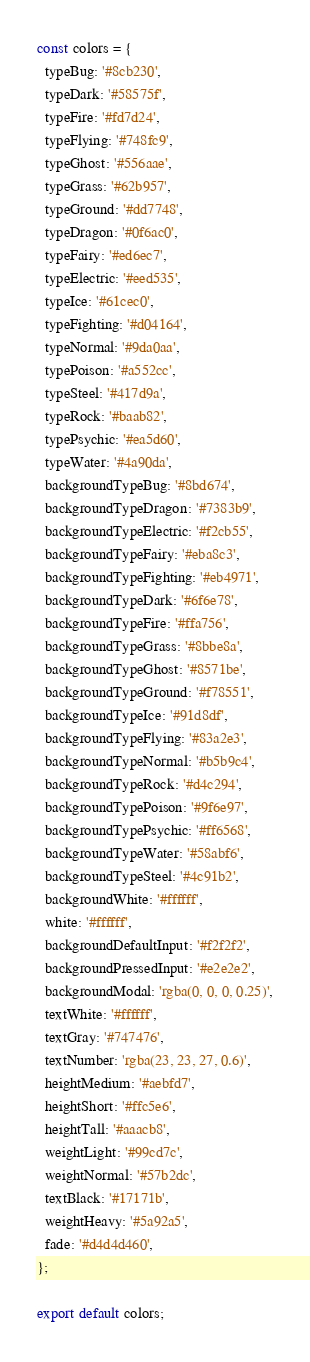<code> <loc_0><loc_0><loc_500><loc_500><_JavaScript_>const colors = {
  typeBug: '#8cb230',
  typeDark: '#58575f',
  typeFire: '#fd7d24',
  typeFlying: '#748fc9',
  typeGhost: '#556aae',
  typeGrass: '#62b957',
  typeGround: '#dd7748',
  typeDragon: '#0f6ac0',
  typeFairy: '#ed6ec7',
  typeElectric: '#eed535',
  typeIce: '#61cec0',
  typeFighting: '#d04164',
  typeNormal: '#9da0aa',
  typePoison: '#a552cc',
  typeSteel: '#417d9a',
  typeRock: '#baab82',
  typePsychic: '#ea5d60',
  typeWater: '#4a90da',
  backgroundTypeBug: '#8bd674',
  backgroundTypeDragon: '#7383b9',
  backgroundTypeElectric: '#f2cb55',
  backgroundTypeFairy: '#eba8c3',
  backgroundTypeFighting: '#eb4971',
  backgroundTypeDark: '#6f6e78',
  backgroundTypeFire: '#ffa756',
  backgroundTypeGrass: '#8bbe8a',
  backgroundTypeGhost: '#8571be',
  backgroundTypeGround: '#f78551',
  backgroundTypeIce: '#91d8df',
  backgroundTypeFlying: '#83a2e3',
  backgroundTypeNormal: '#b5b9c4',
  backgroundTypeRock: '#d4c294',
  backgroundTypePoison: '#9f6e97',
  backgroundTypePsychic: '#ff6568',
  backgroundTypeWater: '#58abf6',
  backgroundTypeSteel: '#4c91b2',
  backgroundWhite: '#ffffff',
  white: '#ffffff',
  backgroundDefaultInput: '#f2f2f2',
  backgroundPressedInput: '#e2e2e2',
  backgroundModal: 'rgba(0, 0, 0, 0.25)',
  textWhite: '#ffffff',
  textGray: '#747476',
  textNumber: 'rgba(23, 23, 27, 0.6)',
  heightMedium: '#aebfd7',
  heightShort: '#ffc5e6',
  heightTall: '#aaacb8',
  weightLight: '#99cd7c',
  weightNormal: '#57b2dc',
  textBlack: '#17171b',
  weightHeavy: '#5a92a5',
  fade: '#d4d4d460',
};

export default colors;
</code> 